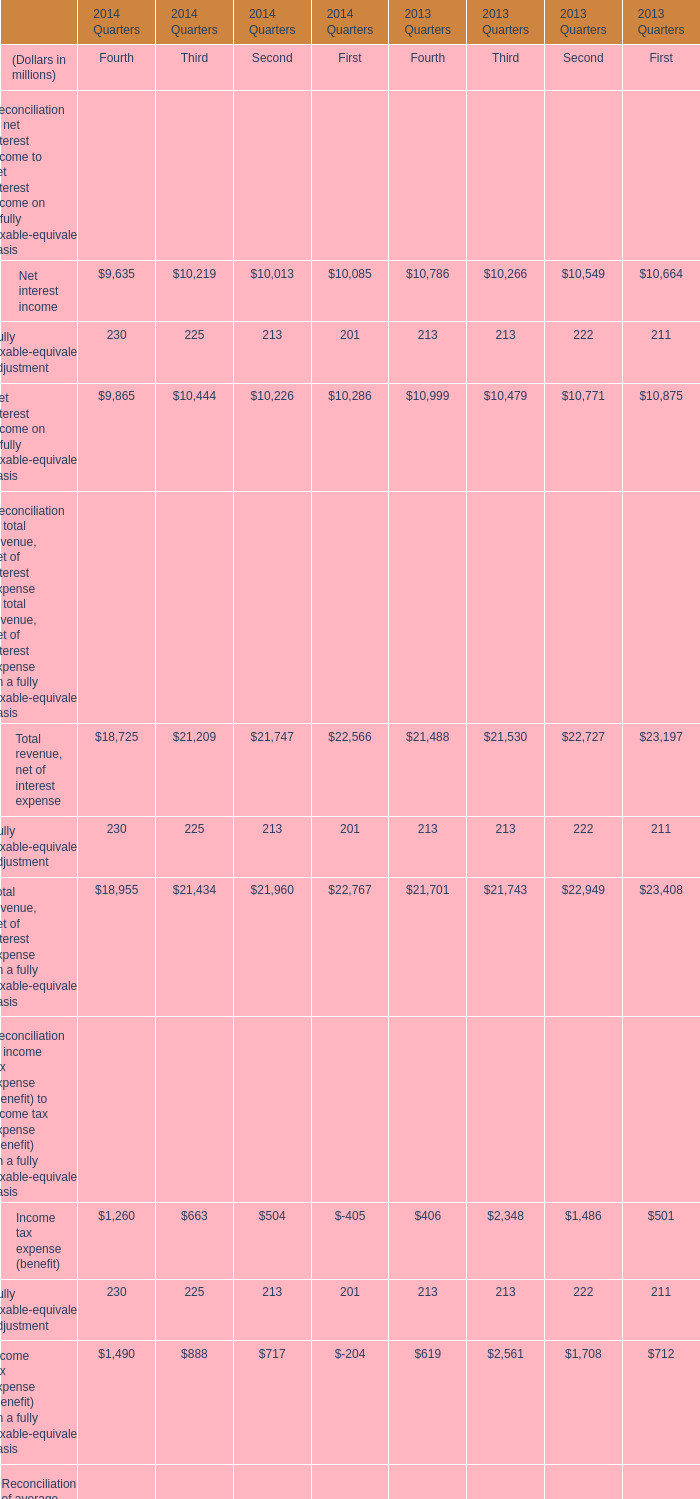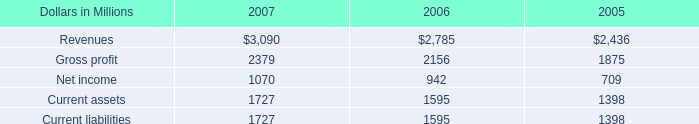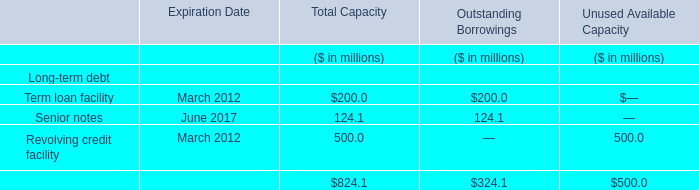What's the average of Net interest income of 2014 Quarters First, and Current assets of 2005 ? 
Computations: ((10085.0 + 1398.0) / 2)
Answer: 5741.5. 